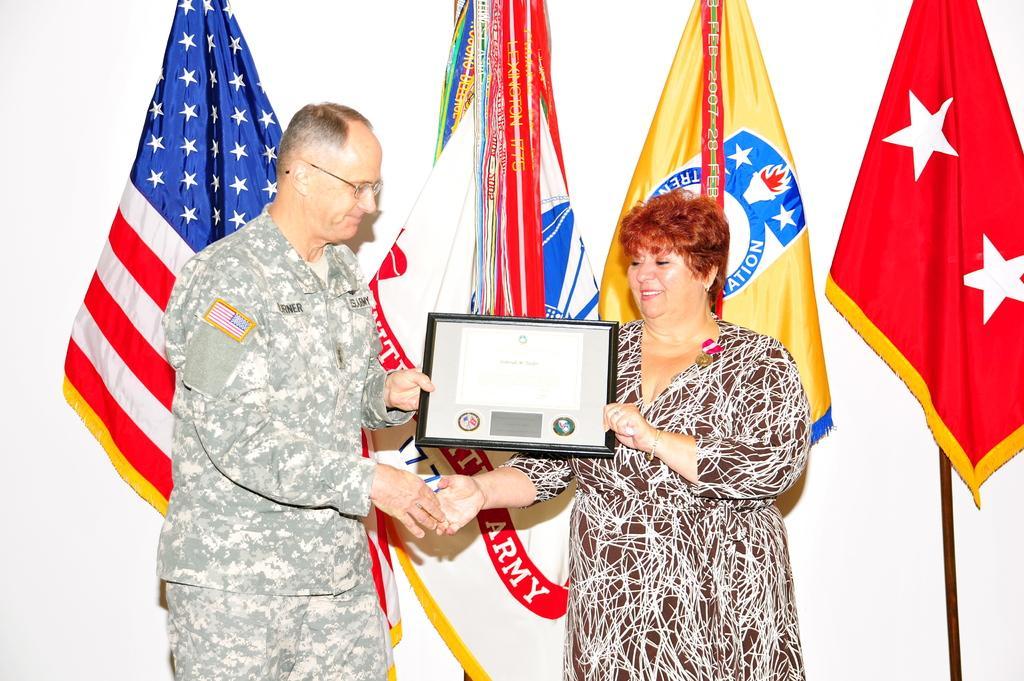Describe this image in one or two sentences. In the picture there is a woman receiving an award from an officer and behind them there are four flags. 